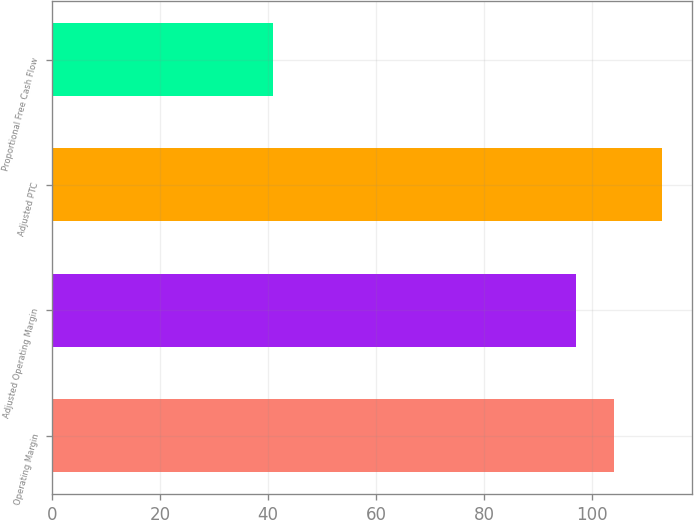<chart> <loc_0><loc_0><loc_500><loc_500><bar_chart><fcel>Operating Margin<fcel>Adjusted Operating Margin<fcel>Adjusted PTC<fcel>Proportional Free Cash Flow<nl><fcel>104.2<fcel>97<fcel>113<fcel>41<nl></chart> 